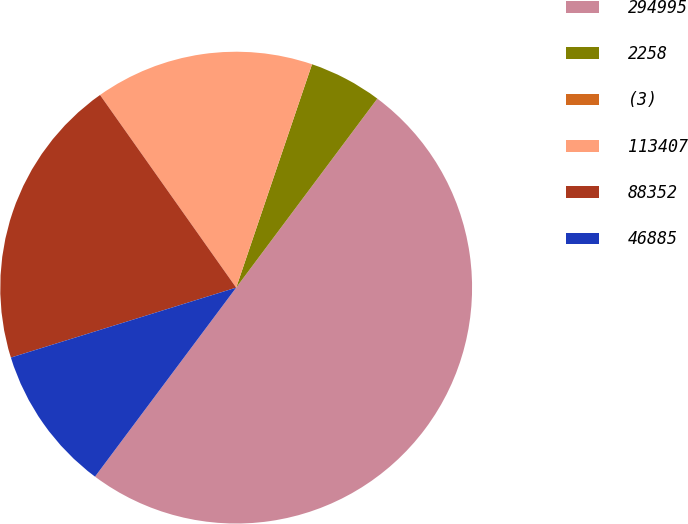<chart> <loc_0><loc_0><loc_500><loc_500><pie_chart><fcel>294995<fcel>2258<fcel>(3)<fcel>113407<fcel>88352<fcel>46885<nl><fcel>50.0%<fcel>5.0%<fcel>0.0%<fcel>15.0%<fcel>20.0%<fcel>10.0%<nl></chart> 